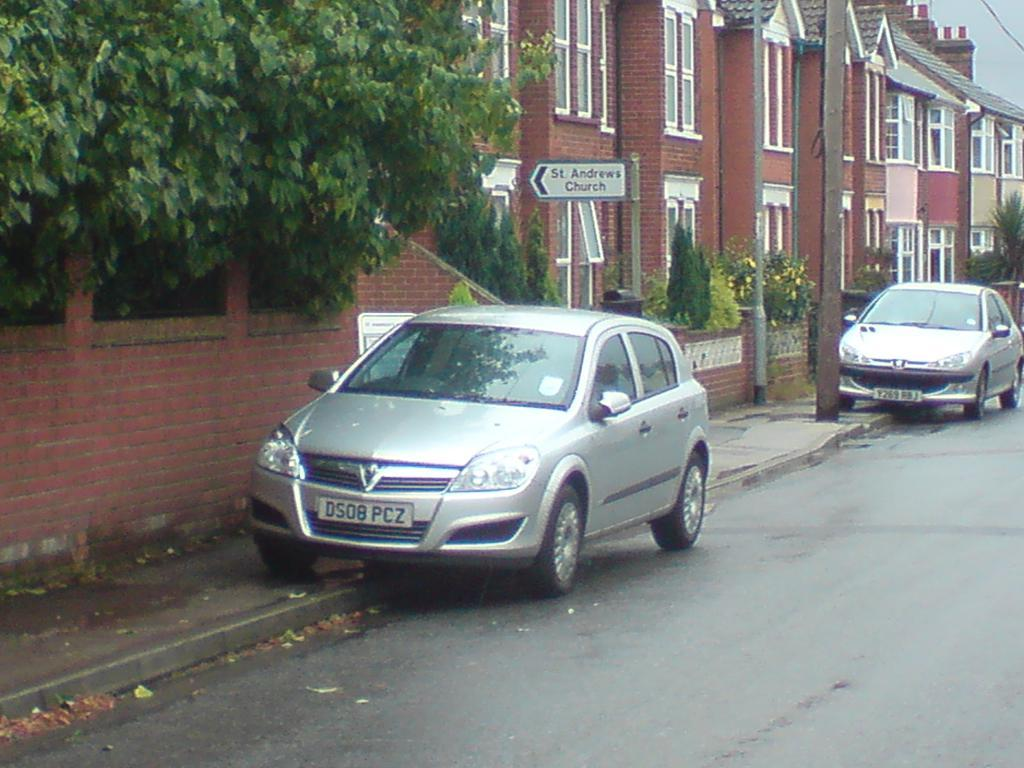What type of vehicles can be seen in the image? There are cars in the image. What can be seen in the distance behind the cars? There are buildings, trees, and a signboard in the background of the image. What type of appliance is being used to create humor in the image? There is no appliance or humor present in the image; it simply shows cars and a background with buildings, trees, and a signboard. 